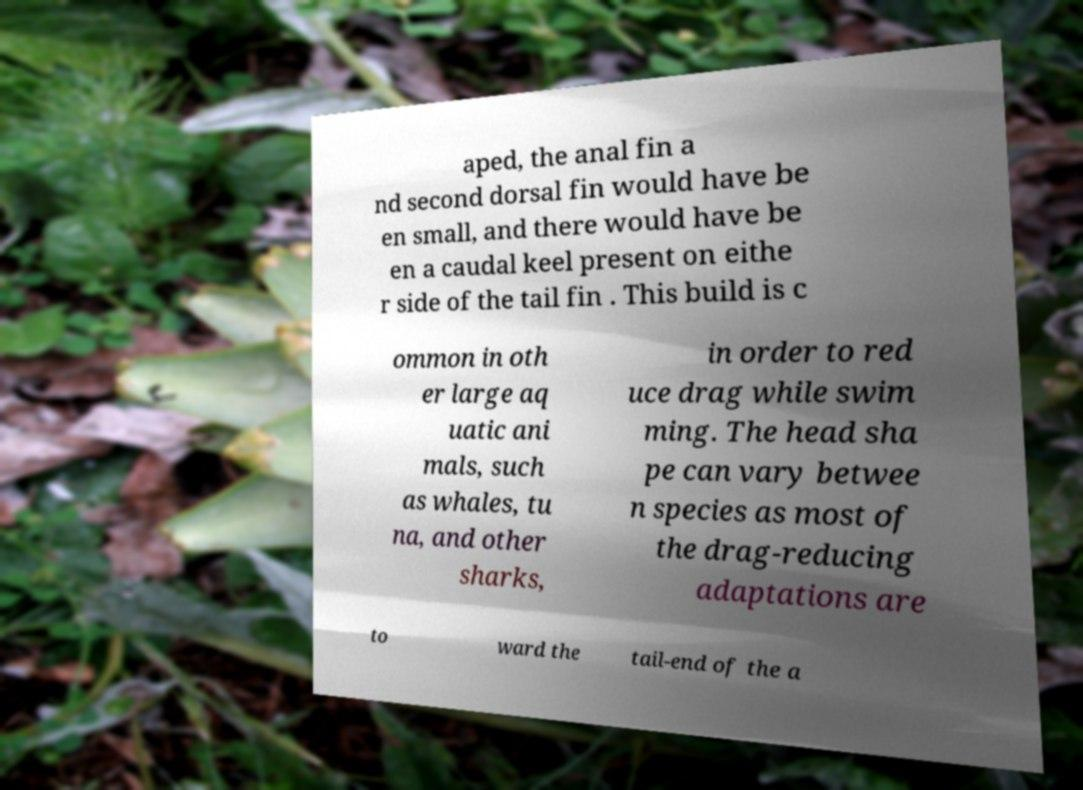I need the written content from this picture converted into text. Can you do that? aped, the anal fin a nd second dorsal fin would have be en small, and there would have be en a caudal keel present on eithe r side of the tail fin . This build is c ommon in oth er large aq uatic ani mals, such as whales, tu na, and other sharks, in order to red uce drag while swim ming. The head sha pe can vary betwee n species as most of the drag-reducing adaptations are to ward the tail-end of the a 